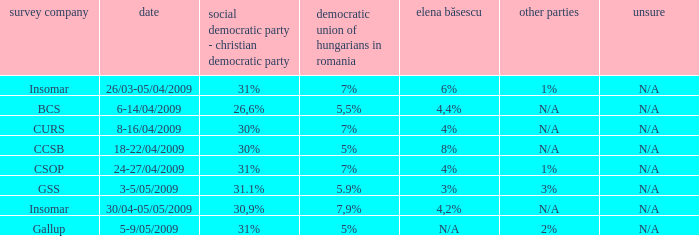What is the psd-pc for 18-22/04/2009? 30%. 